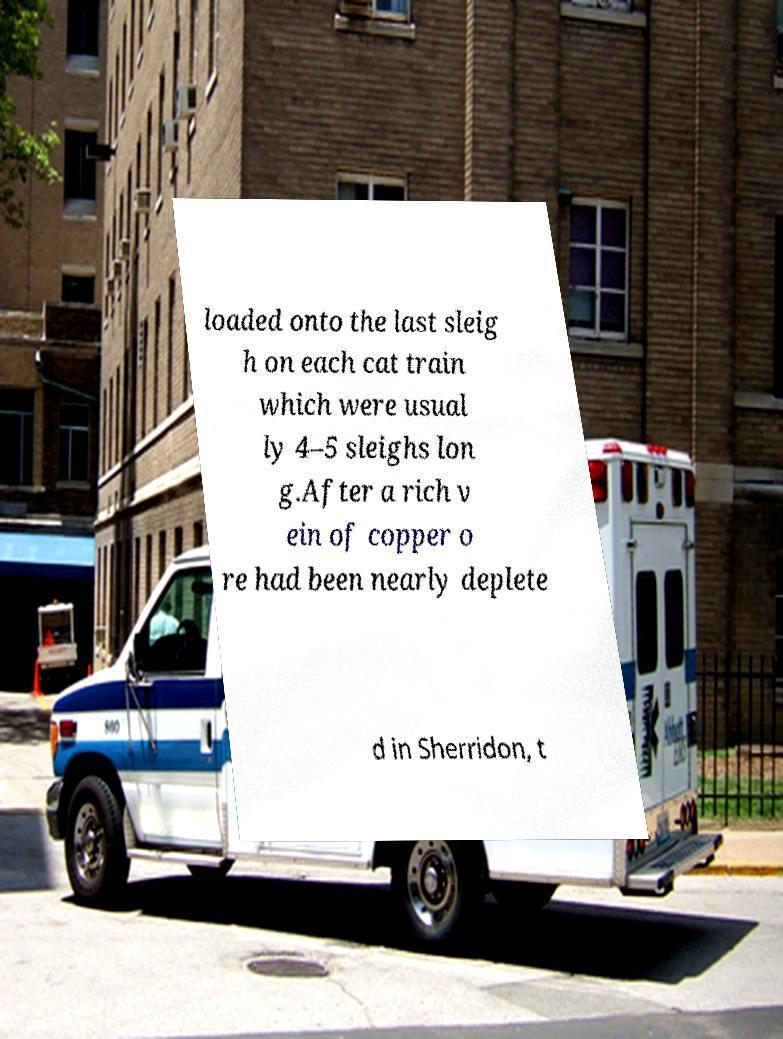Please read and relay the text visible in this image. What does it say? loaded onto the last sleig h on each cat train which were usual ly 4–5 sleighs lon g.After a rich v ein of copper o re had been nearly deplete d in Sherridon, t 